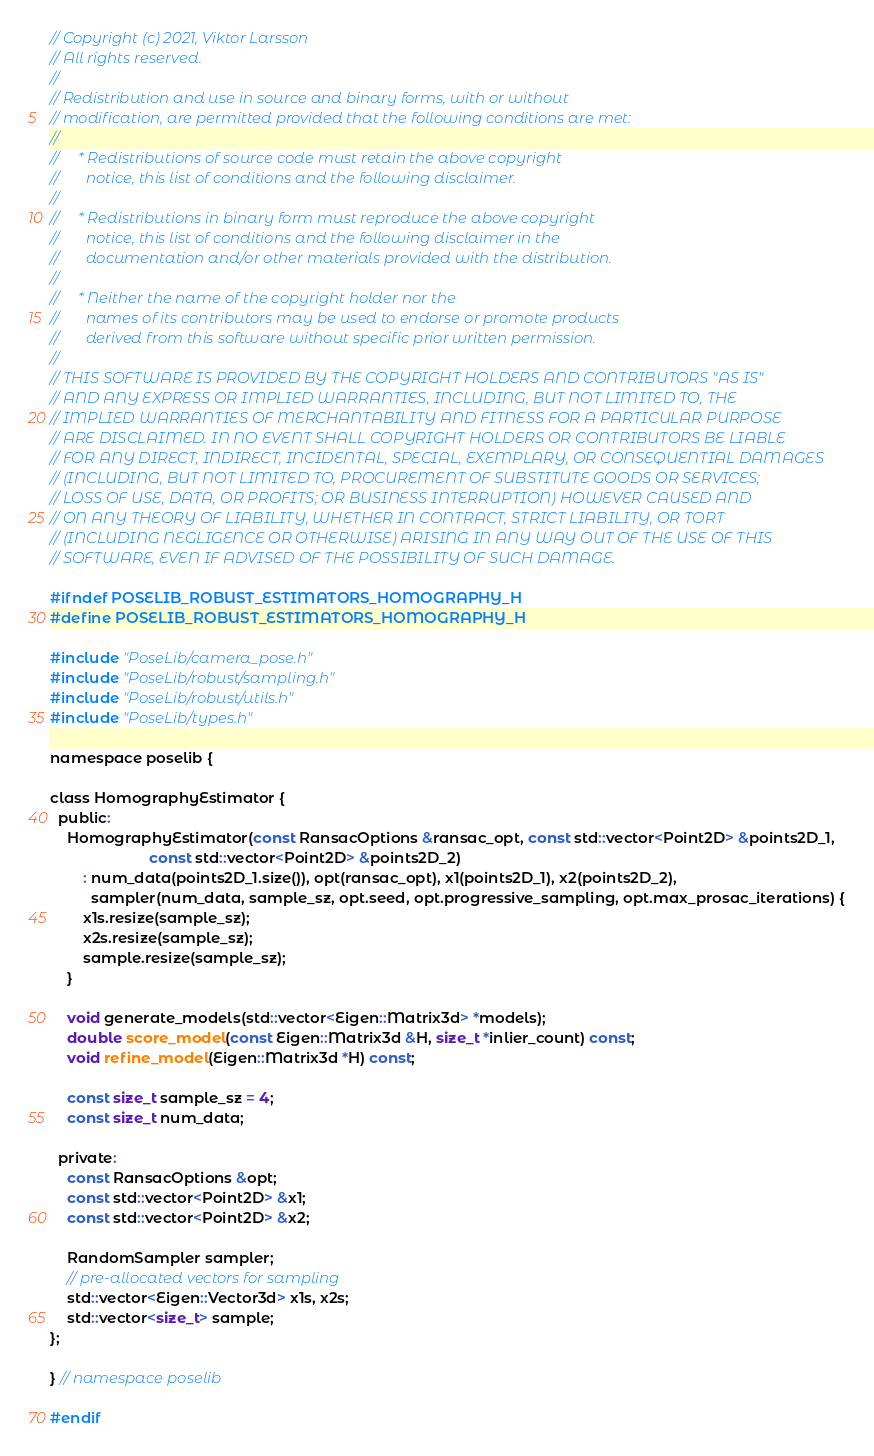Convert code to text. <code><loc_0><loc_0><loc_500><loc_500><_C_>// Copyright (c) 2021, Viktor Larsson
// All rights reserved.
//
// Redistribution and use in source and binary forms, with or without
// modification, are permitted provided that the following conditions are met:
//
//     * Redistributions of source code must retain the above copyright
//       notice, this list of conditions and the following disclaimer.
//
//     * Redistributions in binary form must reproduce the above copyright
//       notice, this list of conditions and the following disclaimer in the
//       documentation and/or other materials provided with the distribution.
//
//     * Neither the name of the copyright holder nor the
//       names of its contributors may be used to endorse or promote products
//       derived from this software without specific prior written permission.
//
// THIS SOFTWARE IS PROVIDED BY THE COPYRIGHT HOLDERS AND CONTRIBUTORS "AS IS"
// AND ANY EXPRESS OR IMPLIED WARRANTIES, INCLUDING, BUT NOT LIMITED TO, THE
// IMPLIED WARRANTIES OF MERCHANTABILITY AND FITNESS FOR A PARTICULAR PURPOSE
// ARE DISCLAIMED. IN NO EVENT SHALL COPYRIGHT HOLDERS OR CONTRIBUTORS BE LIABLE
// FOR ANY DIRECT, INDIRECT, INCIDENTAL, SPECIAL, EXEMPLARY, OR CONSEQUENTIAL DAMAGES
// (INCLUDING, BUT NOT LIMITED TO, PROCUREMENT OF SUBSTITUTE GOODS OR SERVICES;
// LOSS OF USE, DATA, OR PROFITS; OR BUSINESS INTERRUPTION) HOWEVER CAUSED AND
// ON ANY THEORY OF LIABILITY, WHETHER IN CONTRACT, STRICT LIABILITY, OR TORT
// (INCLUDING NEGLIGENCE OR OTHERWISE) ARISING IN ANY WAY OUT OF THE USE OF THIS
// SOFTWARE, EVEN IF ADVISED OF THE POSSIBILITY OF SUCH DAMAGE.

#ifndef POSELIB_ROBUST_ESTIMATORS_HOMOGRAPHY_H
#define POSELIB_ROBUST_ESTIMATORS_HOMOGRAPHY_H

#include "PoseLib/camera_pose.h"
#include "PoseLib/robust/sampling.h"
#include "PoseLib/robust/utils.h"
#include "PoseLib/types.h"

namespace poselib {

class HomographyEstimator {
  public:
    HomographyEstimator(const RansacOptions &ransac_opt, const std::vector<Point2D> &points2D_1,
                        const std::vector<Point2D> &points2D_2)
        : num_data(points2D_1.size()), opt(ransac_opt), x1(points2D_1), x2(points2D_2),
          sampler(num_data, sample_sz, opt.seed, opt.progressive_sampling, opt.max_prosac_iterations) {
        x1s.resize(sample_sz);
        x2s.resize(sample_sz);
        sample.resize(sample_sz);
    }

    void generate_models(std::vector<Eigen::Matrix3d> *models);
    double score_model(const Eigen::Matrix3d &H, size_t *inlier_count) const;
    void refine_model(Eigen::Matrix3d *H) const;

    const size_t sample_sz = 4;
    const size_t num_data;

  private:
    const RansacOptions &opt;
    const std::vector<Point2D> &x1;
    const std::vector<Point2D> &x2;

    RandomSampler sampler;
    // pre-allocated vectors for sampling
    std::vector<Eigen::Vector3d> x1s, x2s;
    std::vector<size_t> sample;
};

} // namespace poselib

#endif</code> 